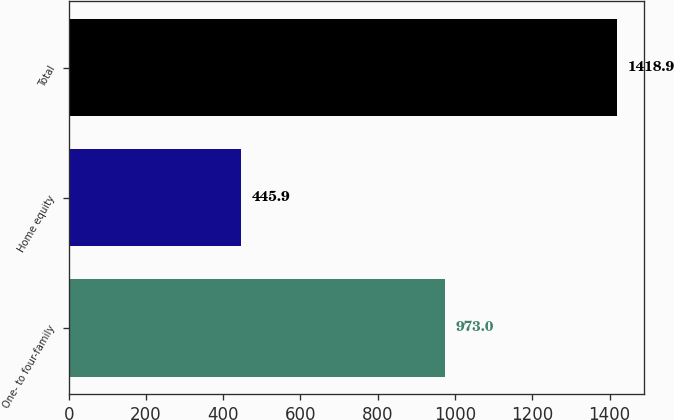Convert chart to OTSL. <chart><loc_0><loc_0><loc_500><loc_500><bar_chart><fcel>One- to four-family<fcel>Home equity<fcel>Total<nl><fcel>973<fcel>445.9<fcel>1418.9<nl></chart> 